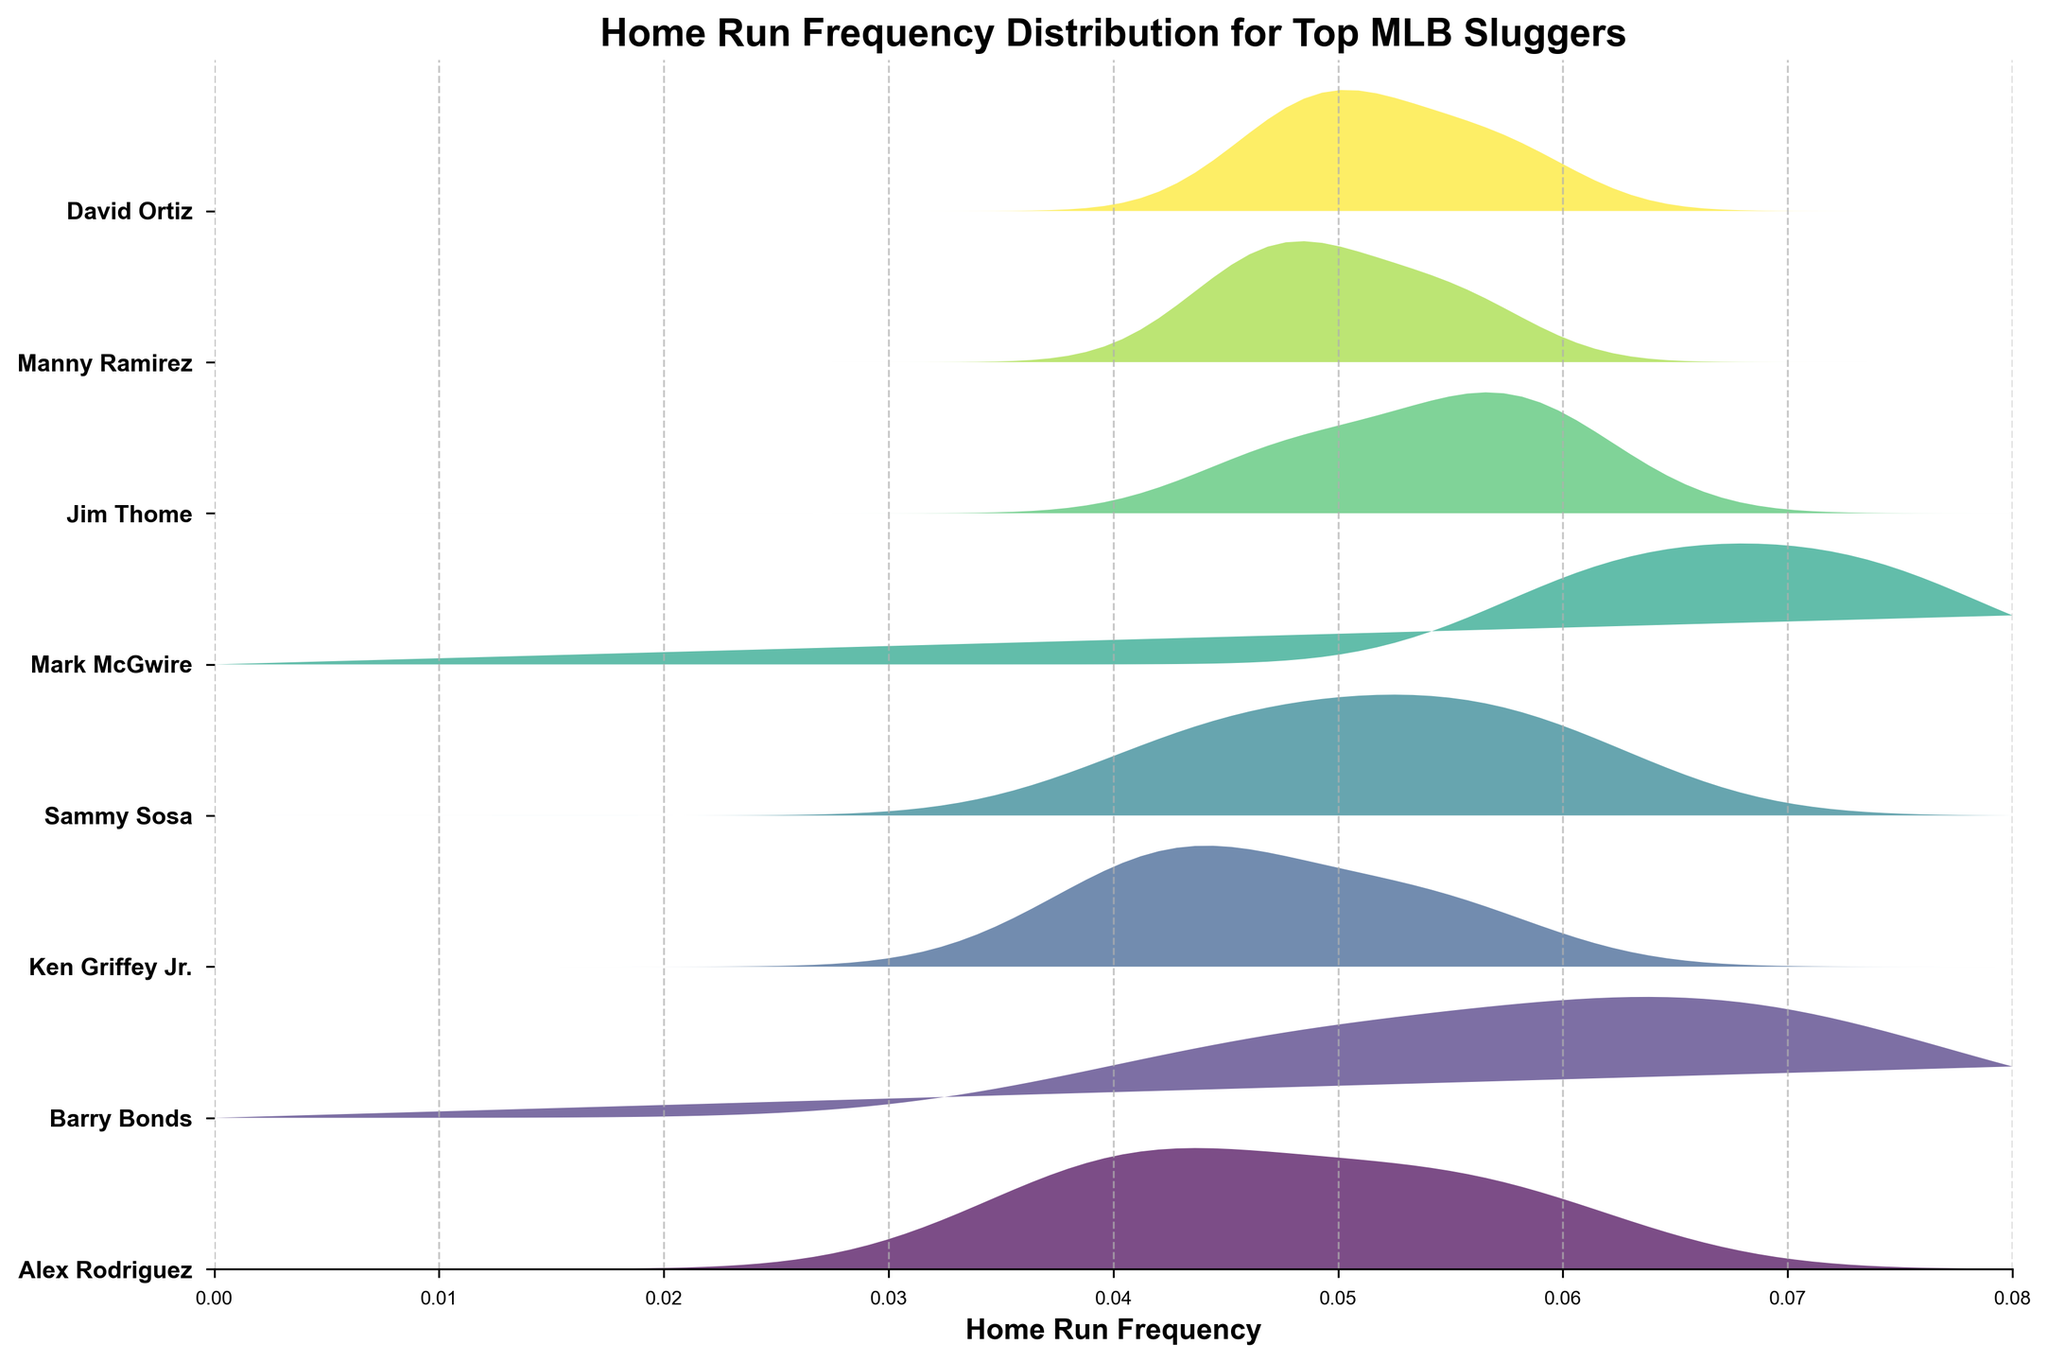Which player has the highest home run frequency in the plot? Look for the player whose distribution peaks the highest on the horizontal axis representing home run frequency. Barry Bonds at AT&T Park
Answer: Barry Bonds What is the range of home run frequencies observed for Alex Rodriguez in Yankee Stadium? Trace from the lowest to the highest point of Alex Rodriguez's distribution specific to Yankee Stadium
Answer: 0.058 How do the home run frequencies of Mark McGwire at Busch Stadium and Coors Field compare? Compare the heights of the distribution peaks for Mark McGwire at Busch Stadium and Coors Field. Higher peak indicates a higher frequency
Answer: Coors Field is higher than Busch Stadium Which player has the most varied home run frequencies across different ballparks? Examine the spread and peak heights for each player's distributions. Look for the player with the widest spread in peaks
Answer: Barry Bonds What is the main visual difference between the distributions of Alex Rodriguez and David Ortiz? Observe their respective ridgeline plots. Contrast where their peaks occur and the overall spread of frequencies
Answer: Alex Rodriguez has wider spread; David Ortiz has more concentrated peaks 